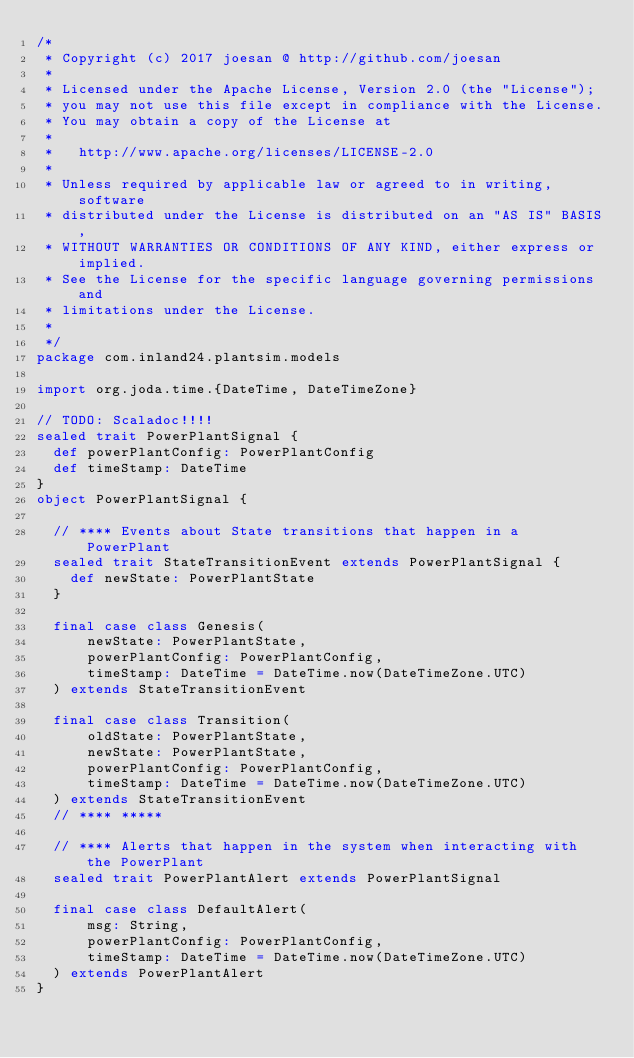Convert code to text. <code><loc_0><loc_0><loc_500><loc_500><_Scala_>/*
 * Copyright (c) 2017 joesan @ http://github.com/joesan
 *
 * Licensed under the Apache License, Version 2.0 (the "License");
 * you may not use this file except in compliance with the License.
 * You may obtain a copy of the License at
 *
 *   http://www.apache.org/licenses/LICENSE-2.0
 *
 * Unless required by applicable law or agreed to in writing, software
 * distributed under the License is distributed on an "AS IS" BASIS,
 * WITHOUT WARRANTIES OR CONDITIONS OF ANY KIND, either express or implied.
 * See the License for the specific language governing permissions and
 * limitations under the License.
 *
 */
package com.inland24.plantsim.models

import org.joda.time.{DateTime, DateTimeZone}

// TODO: Scaladoc!!!!
sealed trait PowerPlantSignal {
  def powerPlantConfig: PowerPlantConfig
  def timeStamp: DateTime
}
object PowerPlantSignal {

  // **** Events about State transitions that happen in a PowerPlant
  sealed trait StateTransitionEvent extends PowerPlantSignal {
    def newState: PowerPlantState
  }

  final case class Genesis(
      newState: PowerPlantState,
      powerPlantConfig: PowerPlantConfig,
      timeStamp: DateTime = DateTime.now(DateTimeZone.UTC)
  ) extends StateTransitionEvent

  final case class Transition(
      oldState: PowerPlantState,
      newState: PowerPlantState,
      powerPlantConfig: PowerPlantConfig,
      timeStamp: DateTime = DateTime.now(DateTimeZone.UTC)
  ) extends StateTransitionEvent
  // **** *****

  // **** Alerts that happen in the system when interacting with the PowerPlant
  sealed trait PowerPlantAlert extends PowerPlantSignal

  final case class DefaultAlert(
      msg: String,
      powerPlantConfig: PowerPlantConfig,
      timeStamp: DateTime = DateTime.now(DateTimeZone.UTC)
  ) extends PowerPlantAlert
}
</code> 